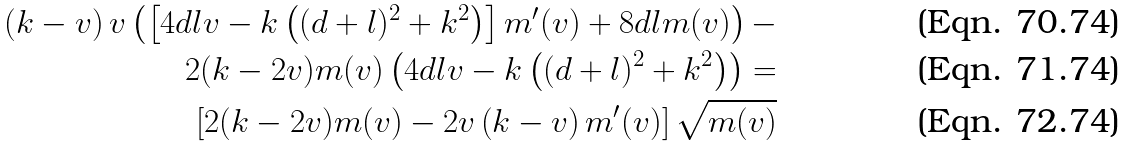Convert formula to latex. <formula><loc_0><loc_0><loc_500><loc_500>\left ( k - v \right ) v \left ( \left [ 4 d l v - k \left ( ( d + l ) ^ { 2 } + k ^ { 2 } \right ) \right ] m ^ { \prime } ( v ) + 8 d l m ( v ) \right ) - \\ 2 ( k - 2 v ) m ( v ) \left ( 4 d l v - k \left ( ( d + l ) ^ { 2 } + k ^ { 2 } \right ) \right ) = \\ \left [ 2 ( k - 2 v ) m ( v ) - 2 v \left ( k - v \right ) m ^ { \prime } ( v ) \right ] \sqrt { m ( v ) }</formula> 